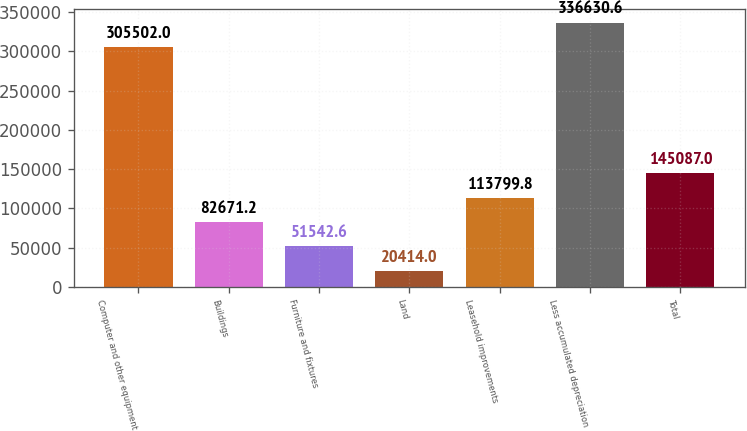Convert chart to OTSL. <chart><loc_0><loc_0><loc_500><loc_500><bar_chart><fcel>Computer and other equipment<fcel>Buildings<fcel>Furniture and fixtures<fcel>Land<fcel>Leasehold improvements<fcel>Less accumulated depreciation<fcel>Total<nl><fcel>305502<fcel>82671.2<fcel>51542.6<fcel>20414<fcel>113800<fcel>336631<fcel>145087<nl></chart> 